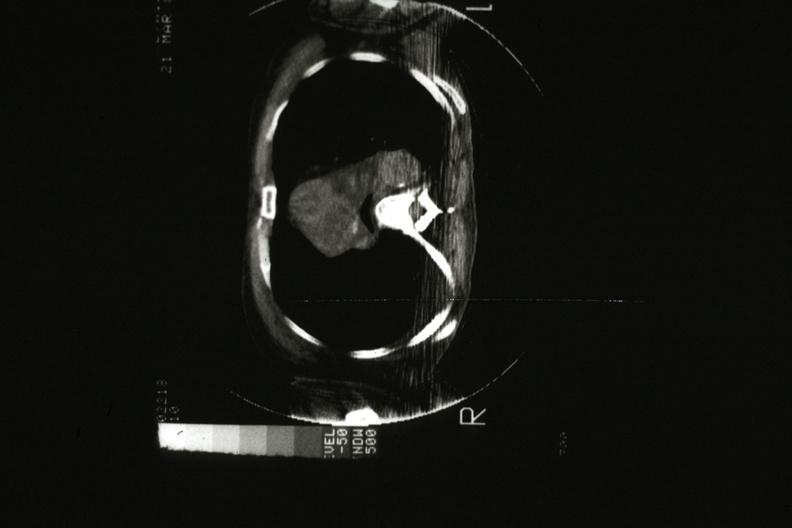s hematologic present?
Answer the question using a single word or phrase. Yes 